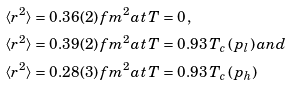Convert formula to latex. <formula><loc_0><loc_0><loc_500><loc_500>\langle r ^ { 2 } \rangle & = 0 . 3 6 ( 2 ) \, f m ^ { 2 } a t \, T = 0 \, , \\ \langle r ^ { 2 } \rangle & = 0 . 3 9 ( 2 ) \, f m ^ { 2 } a t \, T = 0 . 9 3 \, T _ { c } \, ( { p } _ { l } ) \, a n d \\ \langle r ^ { 2 } \rangle & = 0 . 2 8 ( 3 ) \, f m ^ { 2 } a t \, T = 0 . 9 3 \, T _ { c } \, ( { p } _ { h } )</formula> 